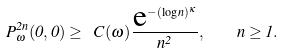Convert formula to latex. <formula><loc_0><loc_0><loc_500><loc_500>P _ { \omega } ^ { 2 n } ( 0 , 0 ) \geq \ C ( \omega ) \frac { \text  e^{-(\log n)^{\kappa}} } { n ^ { 2 } } , \quad n \geq 1 .</formula> 